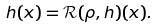Convert formula to latex. <formula><loc_0><loc_0><loc_500><loc_500>h ( x ) = \mathcal { R } ( \rho , h ) ( x ) .</formula> 